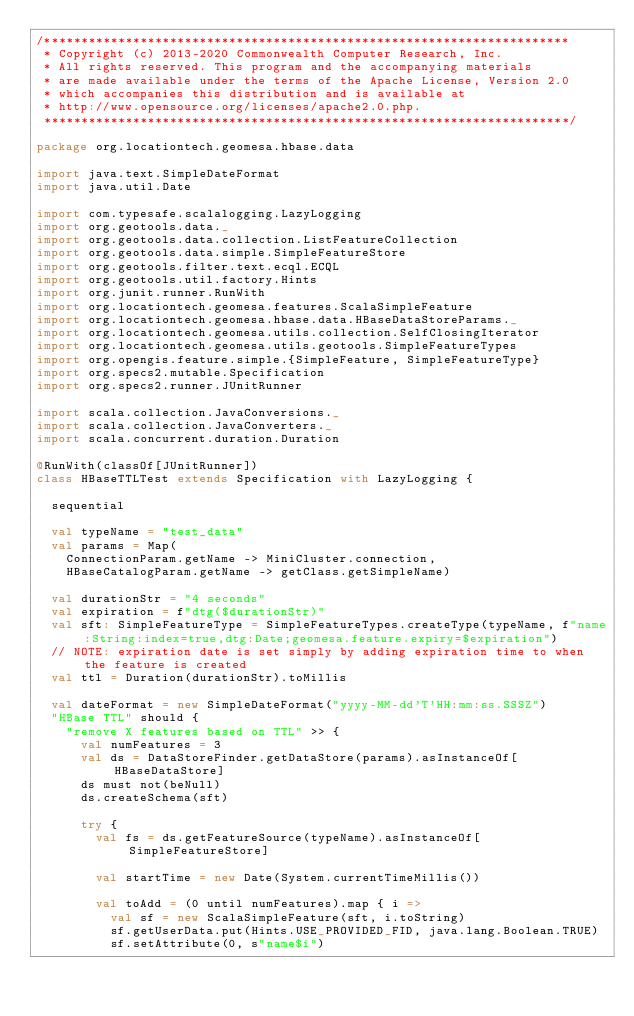<code> <loc_0><loc_0><loc_500><loc_500><_Scala_>/***********************************************************************
 * Copyright (c) 2013-2020 Commonwealth Computer Research, Inc.
 * All rights reserved. This program and the accompanying materials
 * are made available under the terms of the Apache License, Version 2.0
 * which accompanies this distribution and is available at
 * http://www.opensource.org/licenses/apache2.0.php.
 ***********************************************************************/

package org.locationtech.geomesa.hbase.data

import java.text.SimpleDateFormat
import java.util.Date

import com.typesafe.scalalogging.LazyLogging
import org.geotools.data._
import org.geotools.data.collection.ListFeatureCollection
import org.geotools.data.simple.SimpleFeatureStore
import org.geotools.filter.text.ecql.ECQL
import org.geotools.util.factory.Hints
import org.junit.runner.RunWith
import org.locationtech.geomesa.features.ScalaSimpleFeature
import org.locationtech.geomesa.hbase.data.HBaseDataStoreParams._
import org.locationtech.geomesa.utils.collection.SelfClosingIterator
import org.locationtech.geomesa.utils.geotools.SimpleFeatureTypes
import org.opengis.feature.simple.{SimpleFeature, SimpleFeatureType}
import org.specs2.mutable.Specification
import org.specs2.runner.JUnitRunner

import scala.collection.JavaConversions._
import scala.collection.JavaConverters._
import scala.concurrent.duration.Duration

@RunWith(classOf[JUnitRunner])
class HBaseTTLTest extends Specification with LazyLogging {

  sequential

  val typeName = "test_data"
  val params = Map(
    ConnectionParam.getName -> MiniCluster.connection,
    HBaseCatalogParam.getName -> getClass.getSimpleName)

  val durationStr = "4 seconds"
  val expiration = f"dtg($durationStr)"
  val sft: SimpleFeatureType = SimpleFeatureTypes.createType(typeName, f"name:String:index=true,dtg:Date;geomesa.feature.expiry=$expiration")
  // NOTE: expiration date is set simply by adding expiration time to when the feature is created
  val ttl = Duration(durationStr).toMillis

  val dateFormat = new SimpleDateFormat("yyyy-MM-dd'T'HH:mm:ss.SSSZ")
  "HBase TTL" should {
    "remove X features based on TTL" >> {
      val numFeatures = 3
      val ds = DataStoreFinder.getDataStore(params).asInstanceOf[HBaseDataStore]
      ds must not(beNull)
      ds.createSchema(sft)

      try {
        val fs = ds.getFeatureSource(typeName).asInstanceOf[SimpleFeatureStore]

        val startTime = new Date(System.currentTimeMillis())

        val toAdd = (0 until numFeatures).map { i =>
          val sf = new ScalaSimpleFeature(sft, i.toString)
          sf.getUserData.put(Hints.USE_PROVIDED_FID, java.lang.Boolean.TRUE)
          sf.setAttribute(0, s"name$i")
</code> 